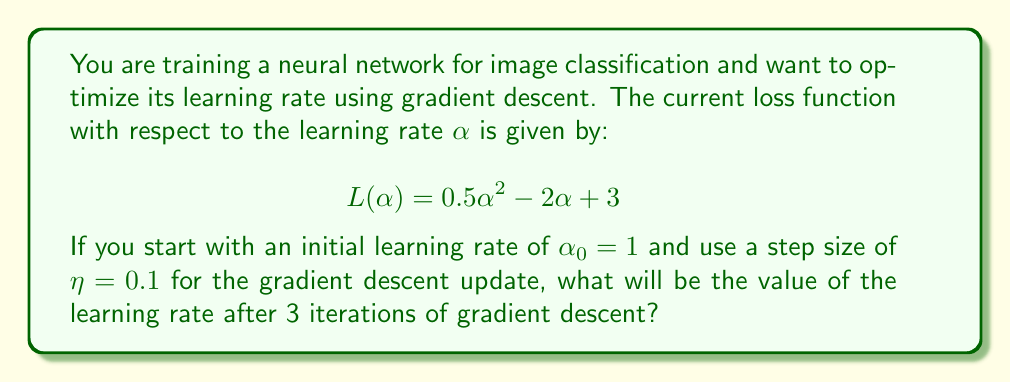Show me your answer to this math problem. To optimize the learning rate using gradient descent, we need to follow these steps:

1. Calculate the derivative of the loss function with respect to $\alpha$:
   $$\frac{dL}{d\alpha} = \alpha - 2$$

2. Use the gradient descent update rule:
   $$\alpha_{t+1} = \alpha_t - \eta \frac{dL}{d\alpha}|_{\alpha=\alpha_t}$$

3. Perform 3 iterations of gradient descent:

   Iteration 1:
   $$\alpha_1 = 1 - 0.1(1 - 2) = 1 - 0.1(-1) = 1.1$$

   Iteration 2:
   $$\alpha_2 = 1.1 - 0.1(1.1 - 2) = 1.1 - 0.1(-0.9) = 1.19$$

   Iteration 3:
   $$\alpha_3 = 1.19 - 0.1(1.19 - 2) = 1.19 - 0.1(-0.81) = 1.271$$

Therefore, after 3 iterations of gradient descent, the learning rate will be approximately 1.271.
Answer: $\alpha_3 \approx 1.271$ 